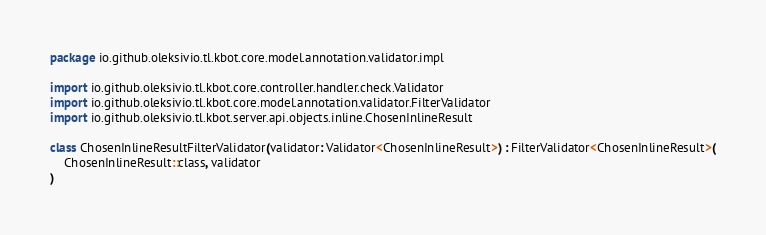Convert code to text. <code><loc_0><loc_0><loc_500><loc_500><_Kotlin_>package io.github.oleksivio.tl.kbot.core.model.annotation.validator.impl

import io.github.oleksivio.tl.kbot.core.controller.handler.check.Validator
import io.github.oleksivio.tl.kbot.core.model.annotation.validator.FilterValidator
import io.github.oleksivio.tl.kbot.server.api.objects.inline.ChosenInlineResult

class ChosenInlineResultFilterValidator(validator: Validator<ChosenInlineResult>) : FilterValidator<ChosenInlineResult>(
    ChosenInlineResult::class, validator
)

</code> 